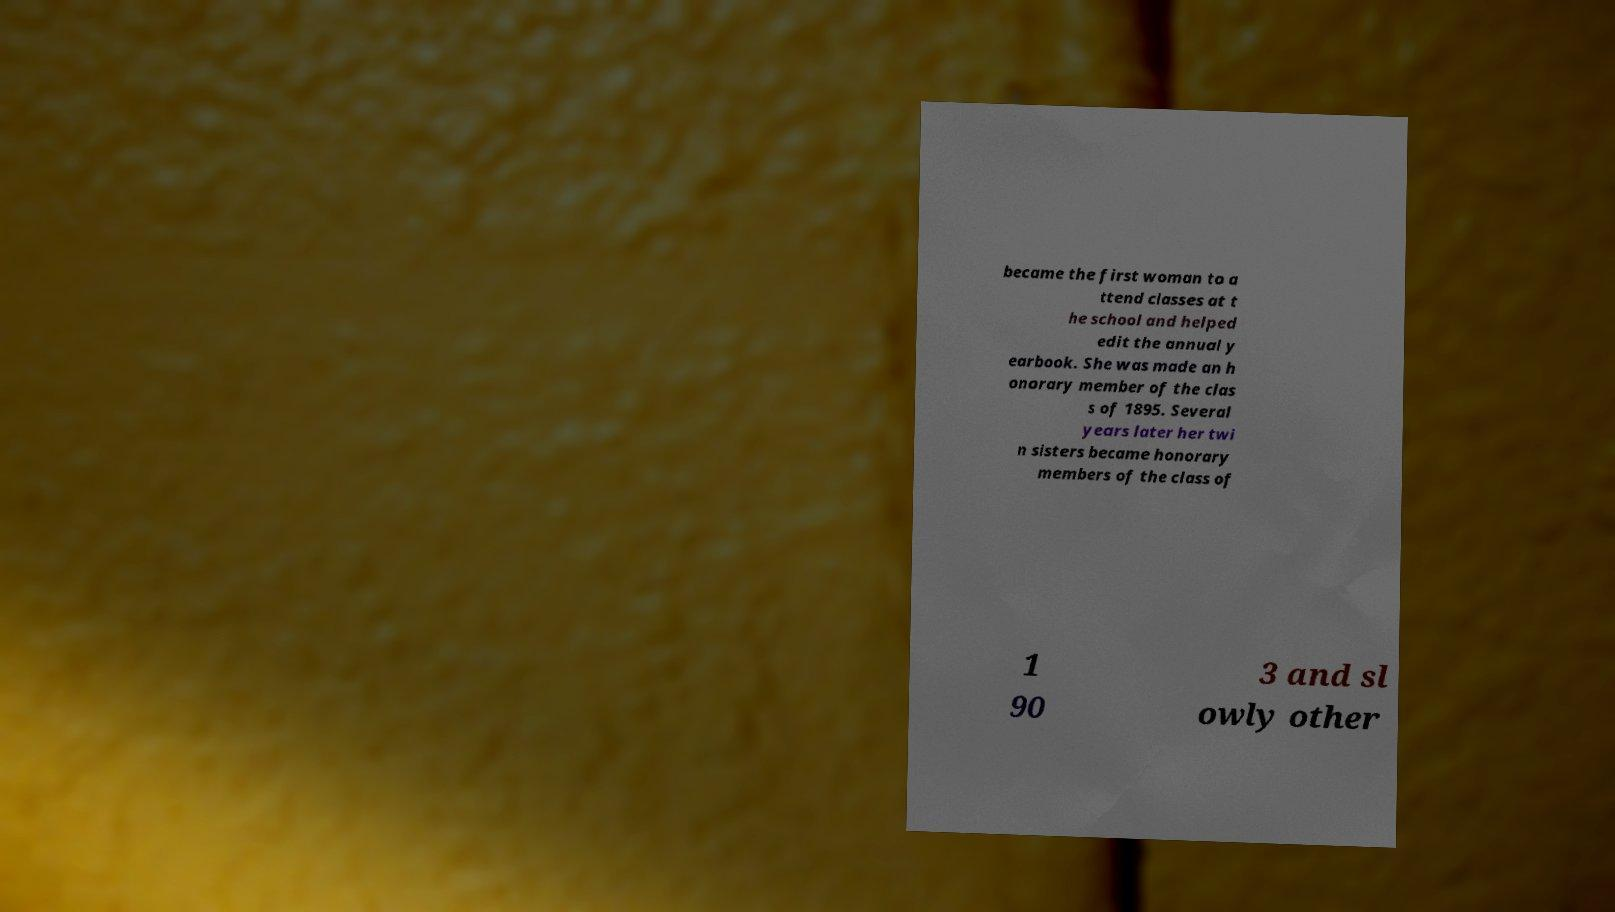Please read and relay the text visible in this image. What does it say? became the first woman to a ttend classes at t he school and helped edit the annual y earbook. She was made an h onorary member of the clas s of 1895. Several years later her twi n sisters became honorary members of the class of 1 90 3 and sl owly other 